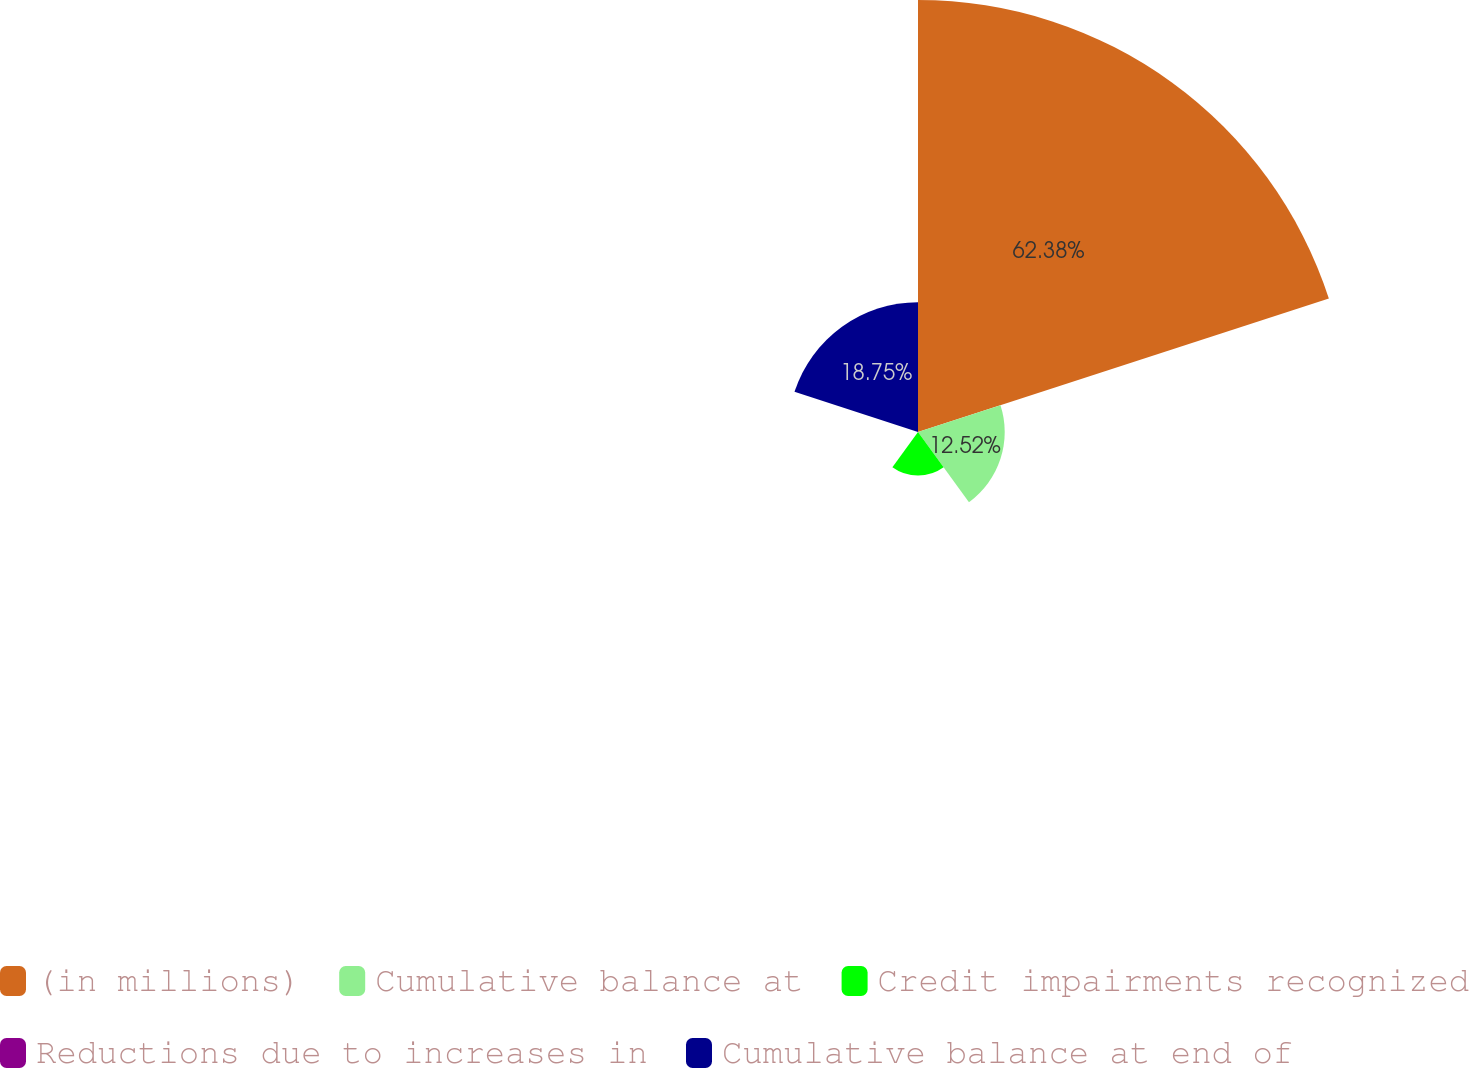Convert chart. <chart><loc_0><loc_0><loc_500><loc_500><pie_chart><fcel>(in millions)<fcel>Cumulative balance at<fcel>Credit impairments recognized<fcel>Reductions due to increases in<fcel>Cumulative balance at end of<nl><fcel>62.37%<fcel>12.52%<fcel>6.29%<fcel>0.06%<fcel>18.75%<nl></chart> 